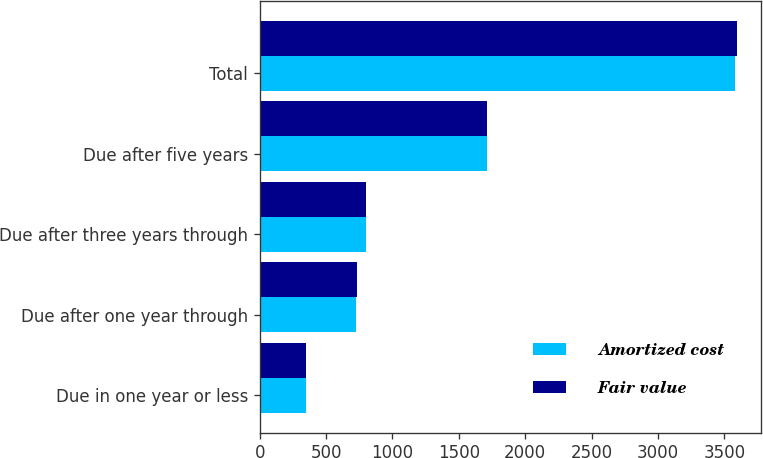Convert chart. <chart><loc_0><loc_0><loc_500><loc_500><stacked_bar_chart><ecel><fcel>Due in one year or less<fcel>Due after one year through<fcel>Due after three years through<fcel>Due after five years<fcel>Total<nl><fcel>Amortized cost<fcel>345.8<fcel>726.3<fcel>800.9<fcel>1709<fcel>3582<nl><fcel>Fair value<fcel>347.8<fcel>734.3<fcel>802<fcel>1711.5<fcel>3595.6<nl></chart> 